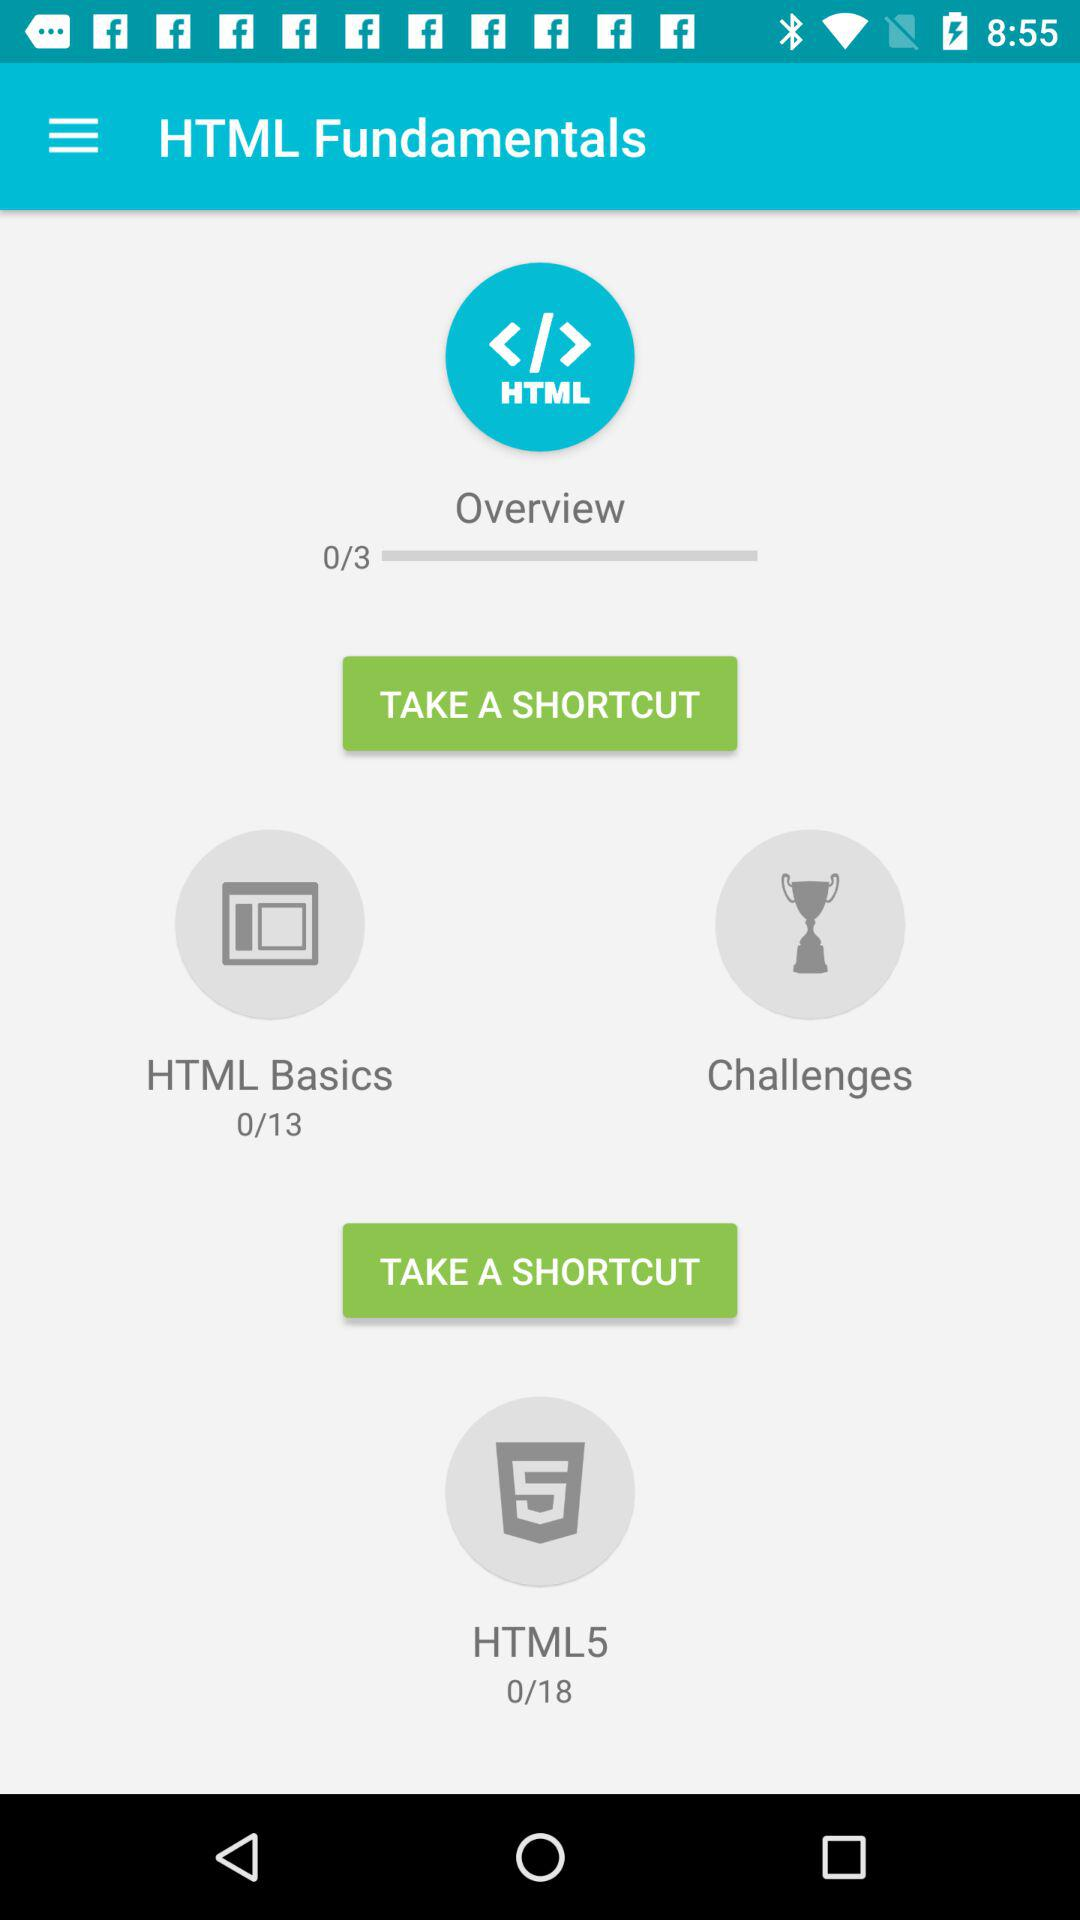How many more lessons are there in HTML5 than HTML Basics?
Answer the question using a single word or phrase. 5 